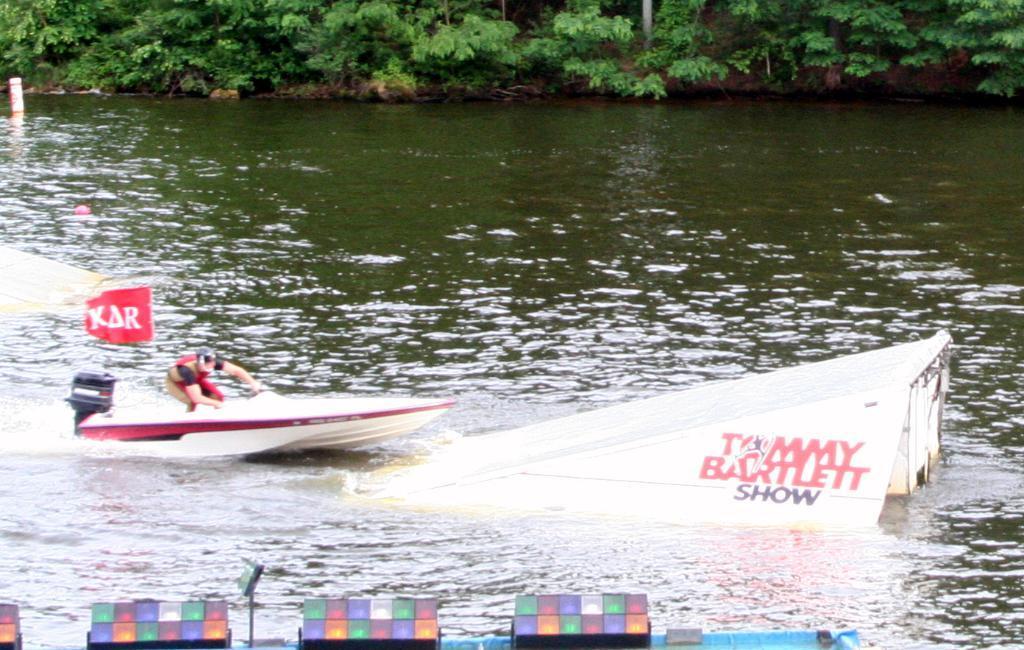Please provide a concise description of this image. In this image we can see a person in the boat which is floating on the water. Here we can see the curved surface and lights here. In the background, we can see the trees. 